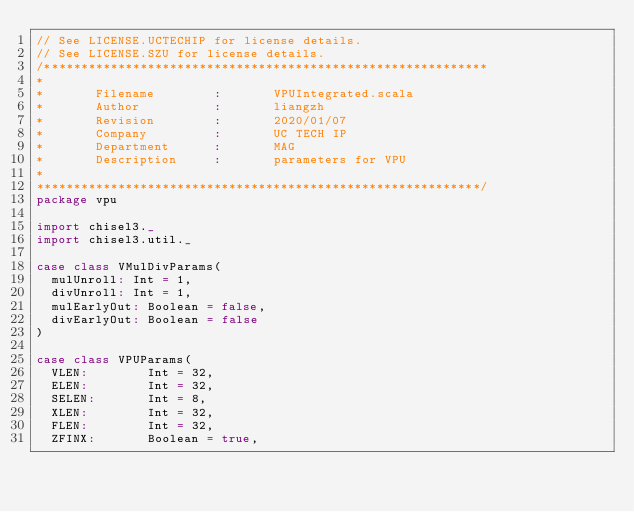<code> <loc_0><loc_0><loc_500><loc_500><_Scala_>// See LICENSE.UCTECHIP for license details.
// See LICENSE.SZU for license details.
/************************************************************
*
*       Filename        :       VPUIntegrated.scala
*       Author          :       liangzh
*       Revision        :       2020/01/07
*       Company         :       UC TECH IP
*       Department      :       MAG
*       Description     :       parameters for VPU
*
************************************************************/
package vpu

import chisel3._
import chisel3.util._

case class VMulDivParams(
  mulUnroll: Int = 1,
  divUnroll: Int = 1,
  mulEarlyOut: Boolean = false,
  divEarlyOut: Boolean = false
)

case class VPUParams(
  VLEN:        Int = 32,
  ELEN:        Int = 32,
  SELEN:       Int = 8,
  XLEN:        Int = 32,
  FLEN:        Int = 32,
  ZFINX:       Boolean = true,</code> 